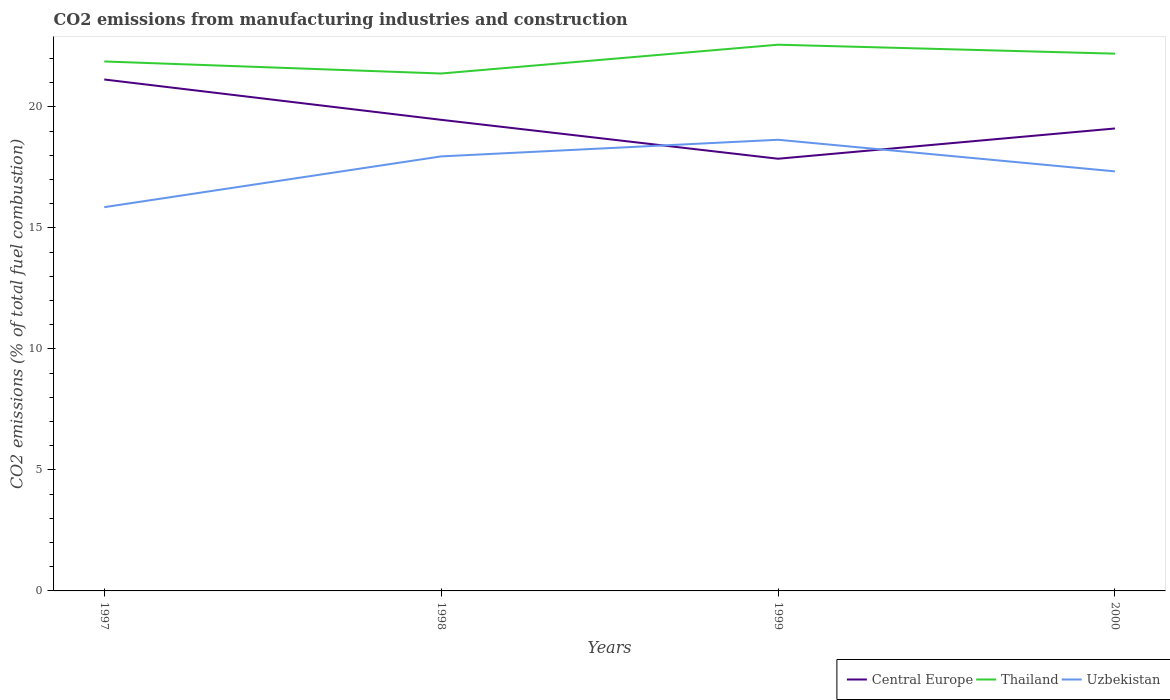Is the number of lines equal to the number of legend labels?
Your response must be concise. Yes. Across all years, what is the maximum amount of CO2 emitted in Thailand?
Your answer should be very brief. 21.38. What is the total amount of CO2 emitted in Central Europe in the graph?
Offer a terse response. 3.27. What is the difference between the highest and the second highest amount of CO2 emitted in Uzbekistan?
Offer a very short reply. 2.78. What is the difference between the highest and the lowest amount of CO2 emitted in Thailand?
Keep it short and to the point. 2. How many lines are there?
Give a very brief answer. 3. What is the difference between two consecutive major ticks on the Y-axis?
Your answer should be compact. 5. Are the values on the major ticks of Y-axis written in scientific E-notation?
Your answer should be compact. No. How are the legend labels stacked?
Give a very brief answer. Horizontal. What is the title of the graph?
Offer a terse response. CO2 emissions from manufacturing industries and construction. Does "Croatia" appear as one of the legend labels in the graph?
Give a very brief answer. No. What is the label or title of the Y-axis?
Make the answer very short. CO2 emissions (% of total fuel combustion). What is the CO2 emissions (% of total fuel combustion) of Central Europe in 1997?
Your answer should be compact. 21.13. What is the CO2 emissions (% of total fuel combustion) of Thailand in 1997?
Offer a terse response. 21.88. What is the CO2 emissions (% of total fuel combustion) in Uzbekistan in 1997?
Keep it short and to the point. 15.86. What is the CO2 emissions (% of total fuel combustion) of Central Europe in 1998?
Ensure brevity in your answer.  19.46. What is the CO2 emissions (% of total fuel combustion) of Thailand in 1998?
Provide a succinct answer. 21.38. What is the CO2 emissions (% of total fuel combustion) in Uzbekistan in 1998?
Make the answer very short. 17.95. What is the CO2 emissions (% of total fuel combustion) in Central Europe in 1999?
Keep it short and to the point. 17.86. What is the CO2 emissions (% of total fuel combustion) of Thailand in 1999?
Give a very brief answer. 22.57. What is the CO2 emissions (% of total fuel combustion) in Uzbekistan in 1999?
Keep it short and to the point. 18.64. What is the CO2 emissions (% of total fuel combustion) in Central Europe in 2000?
Your answer should be compact. 19.11. What is the CO2 emissions (% of total fuel combustion) in Thailand in 2000?
Keep it short and to the point. 22.2. What is the CO2 emissions (% of total fuel combustion) in Uzbekistan in 2000?
Give a very brief answer. 17.33. Across all years, what is the maximum CO2 emissions (% of total fuel combustion) in Central Europe?
Keep it short and to the point. 21.13. Across all years, what is the maximum CO2 emissions (% of total fuel combustion) in Thailand?
Your answer should be very brief. 22.57. Across all years, what is the maximum CO2 emissions (% of total fuel combustion) in Uzbekistan?
Make the answer very short. 18.64. Across all years, what is the minimum CO2 emissions (% of total fuel combustion) of Central Europe?
Keep it short and to the point. 17.86. Across all years, what is the minimum CO2 emissions (% of total fuel combustion) of Thailand?
Offer a very short reply. 21.38. Across all years, what is the minimum CO2 emissions (% of total fuel combustion) of Uzbekistan?
Give a very brief answer. 15.86. What is the total CO2 emissions (% of total fuel combustion) in Central Europe in the graph?
Provide a short and direct response. 77.56. What is the total CO2 emissions (% of total fuel combustion) of Thailand in the graph?
Your answer should be compact. 88.02. What is the total CO2 emissions (% of total fuel combustion) of Uzbekistan in the graph?
Your answer should be very brief. 69.78. What is the difference between the CO2 emissions (% of total fuel combustion) of Central Europe in 1997 and that in 1998?
Provide a succinct answer. 1.67. What is the difference between the CO2 emissions (% of total fuel combustion) in Thailand in 1997 and that in 1998?
Your response must be concise. 0.5. What is the difference between the CO2 emissions (% of total fuel combustion) in Uzbekistan in 1997 and that in 1998?
Keep it short and to the point. -2.1. What is the difference between the CO2 emissions (% of total fuel combustion) in Central Europe in 1997 and that in 1999?
Your answer should be compact. 3.27. What is the difference between the CO2 emissions (% of total fuel combustion) of Thailand in 1997 and that in 1999?
Give a very brief answer. -0.69. What is the difference between the CO2 emissions (% of total fuel combustion) of Uzbekistan in 1997 and that in 1999?
Your answer should be very brief. -2.78. What is the difference between the CO2 emissions (% of total fuel combustion) of Central Europe in 1997 and that in 2000?
Make the answer very short. 2.02. What is the difference between the CO2 emissions (% of total fuel combustion) of Thailand in 1997 and that in 2000?
Keep it short and to the point. -0.32. What is the difference between the CO2 emissions (% of total fuel combustion) of Uzbekistan in 1997 and that in 2000?
Your answer should be compact. -1.48. What is the difference between the CO2 emissions (% of total fuel combustion) in Central Europe in 1998 and that in 1999?
Offer a terse response. 1.61. What is the difference between the CO2 emissions (% of total fuel combustion) of Thailand in 1998 and that in 1999?
Provide a short and direct response. -1.19. What is the difference between the CO2 emissions (% of total fuel combustion) of Uzbekistan in 1998 and that in 1999?
Keep it short and to the point. -0.69. What is the difference between the CO2 emissions (% of total fuel combustion) in Central Europe in 1998 and that in 2000?
Your answer should be compact. 0.36. What is the difference between the CO2 emissions (% of total fuel combustion) in Thailand in 1998 and that in 2000?
Your answer should be very brief. -0.82. What is the difference between the CO2 emissions (% of total fuel combustion) of Uzbekistan in 1998 and that in 2000?
Your answer should be compact. 0.62. What is the difference between the CO2 emissions (% of total fuel combustion) of Central Europe in 1999 and that in 2000?
Your response must be concise. -1.25. What is the difference between the CO2 emissions (% of total fuel combustion) of Thailand in 1999 and that in 2000?
Offer a terse response. 0.37. What is the difference between the CO2 emissions (% of total fuel combustion) of Uzbekistan in 1999 and that in 2000?
Offer a very short reply. 1.31. What is the difference between the CO2 emissions (% of total fuel combustion) in Central Europe in 1997 and the CO2 emissions (% of total fuel combustion) in Thailand in 1998?
Your answer should be very brief. -0.25. What is the difference between the CO2 emissions (% of total fuel combustion) of Central Europe in 1997 and the CO2 emissions (% of total fuel combustion) of Uzbekistan in 1998?
Ensure brevity in your answer.  3.18. What is the difference between the CO2 emissions (% of total fuel combustion) of Thailand in 1997 and the CO2 emissions (% of total fuel combustion) of Uzbekistan in 1998?
Give a very brief answer. 3.92. What is the difference between the CO2 emissions (% of total fuel combustion) of Central Europe in 1997 and the CO2 emissions (% of total fuel combustion) of Thailand in 1999?
Provide a short and direct response. -1.44. What is the difference between the CO2 emissions (% of total fuel combustion) of Central Europe in 1997 and the CO2 emissions (% of total fuel combustion) of Uzbekistan in 1999?
Ensure brevity in your answer.  2.49. What is the difference between the CO2 emissions (% of total fuel combustion) of Thailand in 1997 and the CO2 emissions (% of total fuel combustion) of Uzbekistan in 1999?
Offer a very short reply. 3.24. What is the difference between the CO2 emissions (% of total fuel combustion) in Central Europe in 1997 and the CO2 emissions (% of total fuel combustion) in Thailand in 2000?
Ensure brevity in your answer.  -1.07. What is the difference between the CO2 emissions (% of total fuel combustion) of Central Europe in 1997 and the CO2 emissions (% of total fuel combustion) of Uzbekistan in 2000?
Offer a terse response. 3.8. What is the difference between the CO2 emissions (% of total fuel combustion) in Thailand in 1997 and the CO2 emissions (% of total fuel combustion) in Uzbekistan in 2000?
Provide a short and direct response. 4.54. What is the difference between the CO2 emissions (% of total fuel combustion) of Central Europe in 1998 and the CO2 emissions (% of total fuel combustion) of Thailand in 1999?
Your response must be concise. -3.1. What is the difference between the CO2 emissions (% of total fuel combustion) of Central Europe in 1998 and the CO2 emissions (% of total fuel combustion) of Uzbekistan in 1999?
Provide a succinct answer. 0.82. What is the difference between the CO2 emissions (% of total fuel combustion) of Thailand in 1998 and the CO2 emissions (% of total fuel combustion) of Uzbekistan in 1999?
Keep it short and to the point. 2.74. What is the difference between the CO2 emissions (% of total fuel combustion) of Central Europe in 1998 and the CO2 emissions (% of total fuel combustion) of Thailand in 2000?
Ensure brevity in your answer.  -2.73. What is the difference between the CO2 emissions (% of total fuel combustion) of Central Europe in 1998 and the CO2 emissions (% of total fuel combustion) of Uzbekistan in 2000?
Provide a succinct answer. 2.13. What is the difference between the CO2 emissions (% of total fuel combustion) of Thailand in 1998 and the CO2 emissions (% of total fuel combustion) of Uzbekistan in 2000?
Ensure brevity in your answer.  4.04. What is the difference between the CO2 emissions (% of total fuel combustion) in Central Europe in 1999 and the CO2 emissions (% of total fuel combustion) in Thailand in 2000?
Your response must be concise. -4.34. What is the difference between the CO2 emissions (% of total fuel combustion) in Central Europe in 1999 and the CO2 emissions (% of total fuel combustion) in Uzbekistan in 2000?
Your answer should be very brief. 0.52. What is the difference between the CO2 emissions (% of total fuel combustion) in Thailand in 1999 and the CO2 emissions (% of total fuel combustion) in Uzbekistan in 2000?
Provide a succinct answer. 5.23. What is the average CO2 emissions (% of total fuel combustion) of Central Europe per year?
Your answer should be very brief. 19.39. What is the average CO2 emissions (% of total fuel combustion) in Thailand per year?
Provide a succinct answer. 22.01. What is the average CO2 emissions (% of total fuel combustion) of Uzbekistan per year?
Keep it short and to the point. 17.45. In the year 1997, what is the difference between the CO2 emissions (% of total fuel combustion) of Central Europe and CO2 emissions (% of total fuel combustion) of Thailand?
Offer a terse response. -0.75. In the year 1997, what is the difference between the CO2 emissions (% of total fuel combustion) of Central Europe and CO2 emissions (% of total fuel combustion) of Uzbekistan?
Make the answer very short. 5.27. In the year 1997, what is the difference between the CO2 emissions (% of total fuel combustion) in Thailand and CO2 emissions (% of total fuel combustion) in Uzbekistan?
Your response must be concise. 6.02. In the year 1998, what is the difference between the CO2 emissions (% of total fuel combustion) of Central Europe and CO2 emissions (% of total fuel combustion) of Thailand?
Provide a short and direct response. -1.91. In the year 1998, what is the difference between the CO2 emissions (% of total fuel combustion) of Central Europe and CO2 emissions (% of total fuel combustion) of Uzbekistan?
Your answer should be compact. 1.51. In the year 1998, what is the difference between the CO2 emissions (% of total fuel combustion) in Thailand and CO2 emissions (% of total fuel combustion) in Uzbekistan?
Give a very brief answer. 3.42. In the year 1999, what is the difference between the CO2 emissions (% of total fuel combustion) of Central Europe and CO2 emissions (% of total fuel combustion) of Thailand?
Your answer should be very brief. -4.71. In the year 1999, what is the difference between the CO2 emissions (% of total fuel combustion) of Central Europe and CO2 emissions (% of total fuel combustion) of Uzbekistan?
Offer a terse response. -0.78. In the year 1999, what is the difference between the CO2 emissions (% of total fuel combustion) in Thailand and CO2 emissions (% of total fuel combustion) in Uzbekistan?
Your answer should be compact. 3.93. In the year 2000, what is the difference between the CO2 emissions (% of total fuel combustion) in Central Europe and CO2 emissions (% of total fuel combustion) in Thailand?
Your response must be concise. -3.09. In the year 2000, what is the difference between the CO2 emissions (% of total fuel combustion) of Central Europe and CO2 emissions (% of total fuel combustion) of Uzbekistan?
Provide a short and direct response. 1.77. In the year 2000, what is the difference between the CO2 emissions (% of total fuel combustion) of Thailand and CO2 emissions (% of total fuel combustion) of Uzbekistan?
Give a very brief answer. 4.86. What is the ratio of the CO2 emissions (% of total fuel combustion) in Central Europe in 1997 to that in 1998?
Your response must be concise. 1.09. What is the ratio of the CO2 emissions (% of total fuel combustion) of Thailand in 1997 to that in 1998?
Your answer should be compact. 1.02. What is the ratio of the CO2 emissions (% of total fuel combustion) in Uzbekistan in 1997 to that in 1998?
Provide a short and direct response. 0.88. What is the ratio of the CO2 emissions (% of total fuel combustion) in Central Europe in 1997 to that in 1999?
Keep it short and to the point. 1.18. What is the ratio of the CO2 emissions (% of total fuel combustion) of Thailand in 1997 to that in 1999?
Offer a terse response. 0.97. What is the ratio of the CO2 emissions (% of total fuel combustion) of Uzbekistan in 1997 to that in 1999?
Your response must be concise. 0.85. What is the ratio of the CO2 emissions (% of total fuel combustion) in Central Europe in 1997 to that in 2000?
Offer a terse response. 1.11. What is the ratio of the CO2 emissions (% of total fuel combustion) in Thailand in 1997 to that in 2000?
Keep it short and to the point. 0.99. What is the ratio of the CO2 emissions (% of total fuel combustion) of Uzbekistan in 1997 to that in 2000?
Provide a succinct answer. 0.91. What is the ratio of the CO2 emissions (% of total fuel combustion) in Central Europe in 1998 to that in 1999?
Your response must be concise. 1.09. What is the ratio of the CO2 emissions (% of total fuel combustion) in Thailand in 1998 to that in 1999?
Provide a short and direct response. 0.95. What is the ratio of the CO2 emissions (% of total fuel combustion) in Uzbekistan in 1998 to that in 1999?
Keep it short and to the point. 0.96. What is the ratio of the CO2 emissions (% of total fuel combustion) of Central Europe in 1998 to that in 2000?
Ensure brevity in your answer.  1.02. What is the ratio of the CO2 emissions (% of total fuel combustion) in Uzbekistan in 1998 to that in 2000?
Offer a terse response. 1.04. What is the ratio of the CO2 emissions (% of total fuel combustion) in Central Europe in 1999 to that in 2000?
Give a very brief answer. 0.93. What is the ratio of the CO2 emissions (% of total fuel combustion) of Thailand in 1999 to that in 2000?
Provide a succinct answer. 1.02. What is the ratio of the CO2 emissions (% of total fuel combustion) in Uzbekistan in 1999 to that in 2000?
Provide a short and direct response. 1.08. What is the difference between the highest and the second highest CO2 emissions (% of total fuel combustion) of Central Europe?
Your answer should be very brief. 1.67. What is the difference between the highest and the second highest CO2 emissions (% of total fuel combustion) of Thailand?
Your answer should be very brief. 0.37. What is the difference between the highest and the second highest CO2 emissions (% of total fuel combustion) of Uzbekistan?
Offer a terse response. 0.69. What is the difference between the highest and the lowest CO2 emissions (% of total fuel combustion) in Central Europe?
Make the answer very short. 3.27. What is the difference between the highest and the lowest CO2 emissions (% of total fuel combustion) in Thailand?
Offer a very short reply. 1.19. What is the difference between the highest and the lowest CO2 emissions (% of total fuel combustion) in Uzbekistan?
Make the answer very short. 2.78. 